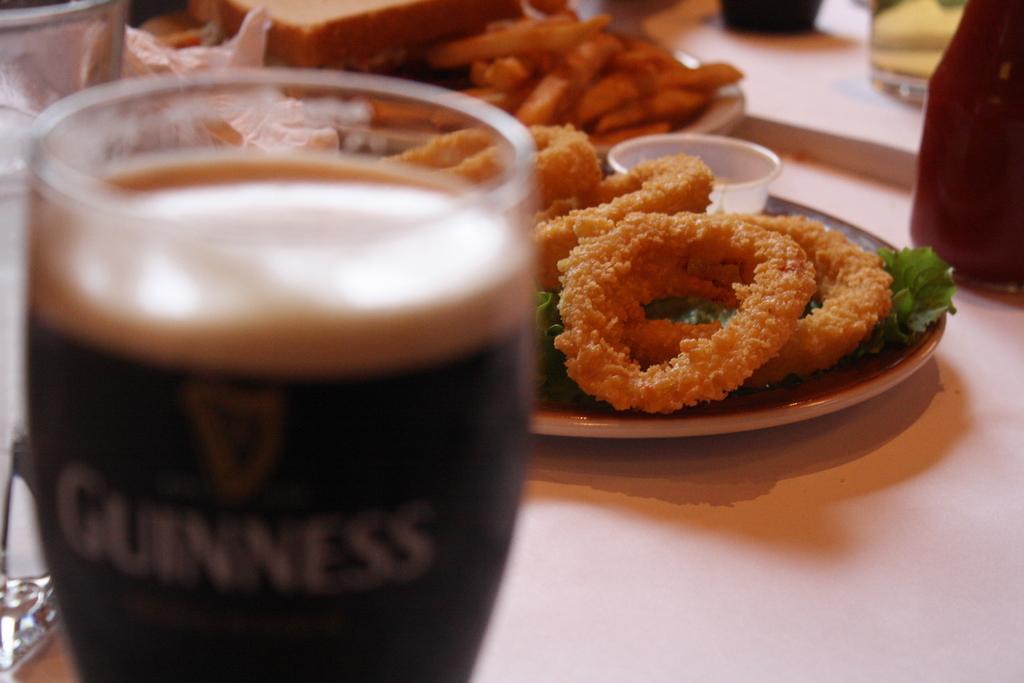Please provide a concise description of this image. There is a glass in the foreground area of the image and food items in the background. 